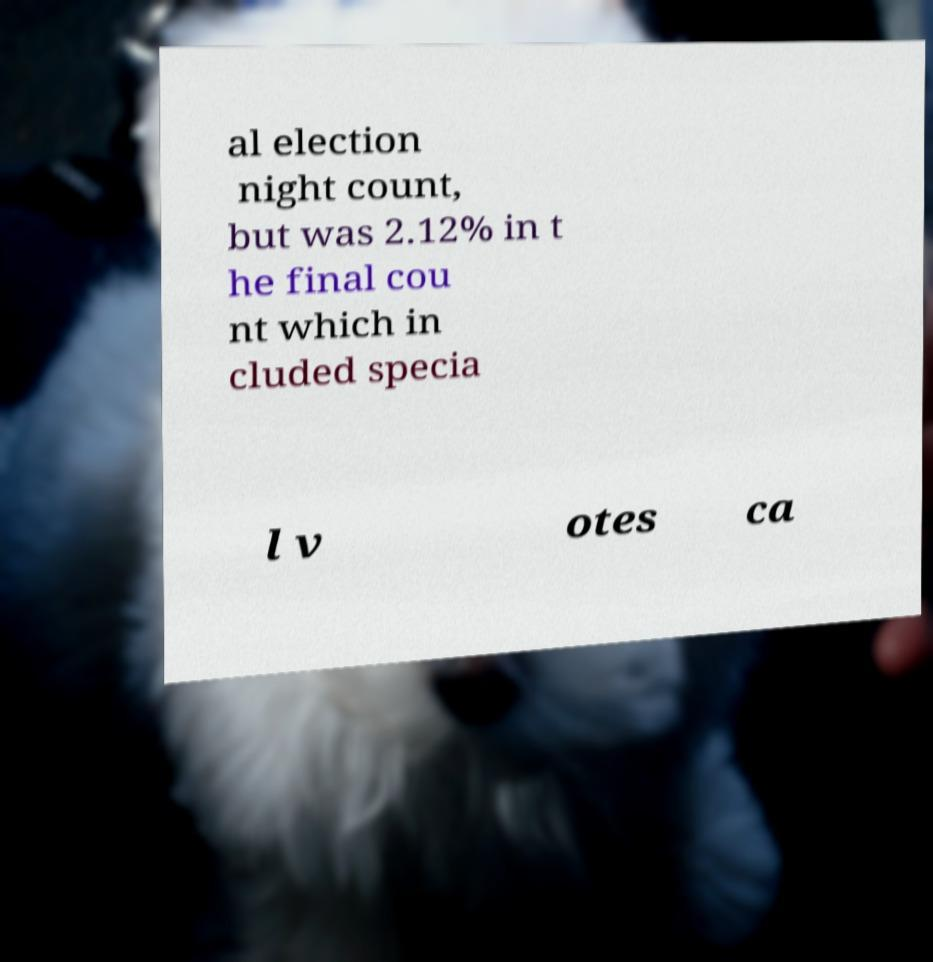Please identify and transcribe the text found in this image. al election night count, but was 2.12% in t he final cou nt which in cluded specia l v otes ca 